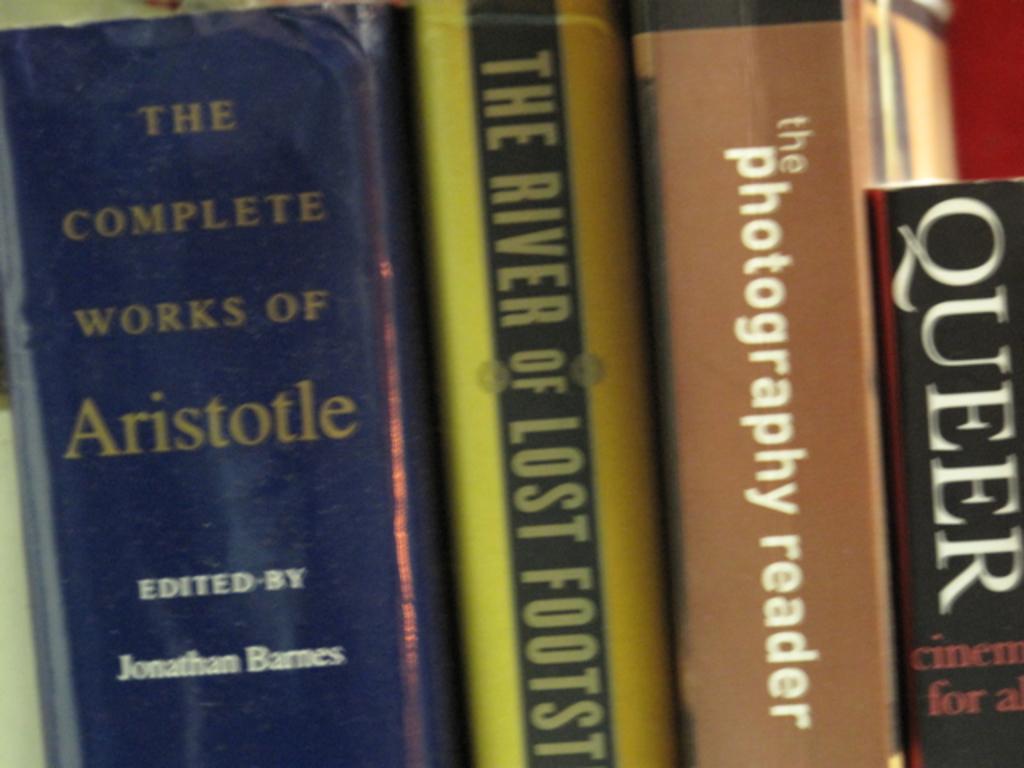What's the title of the rightmost book?
Provide a short and direct response. Queer. 